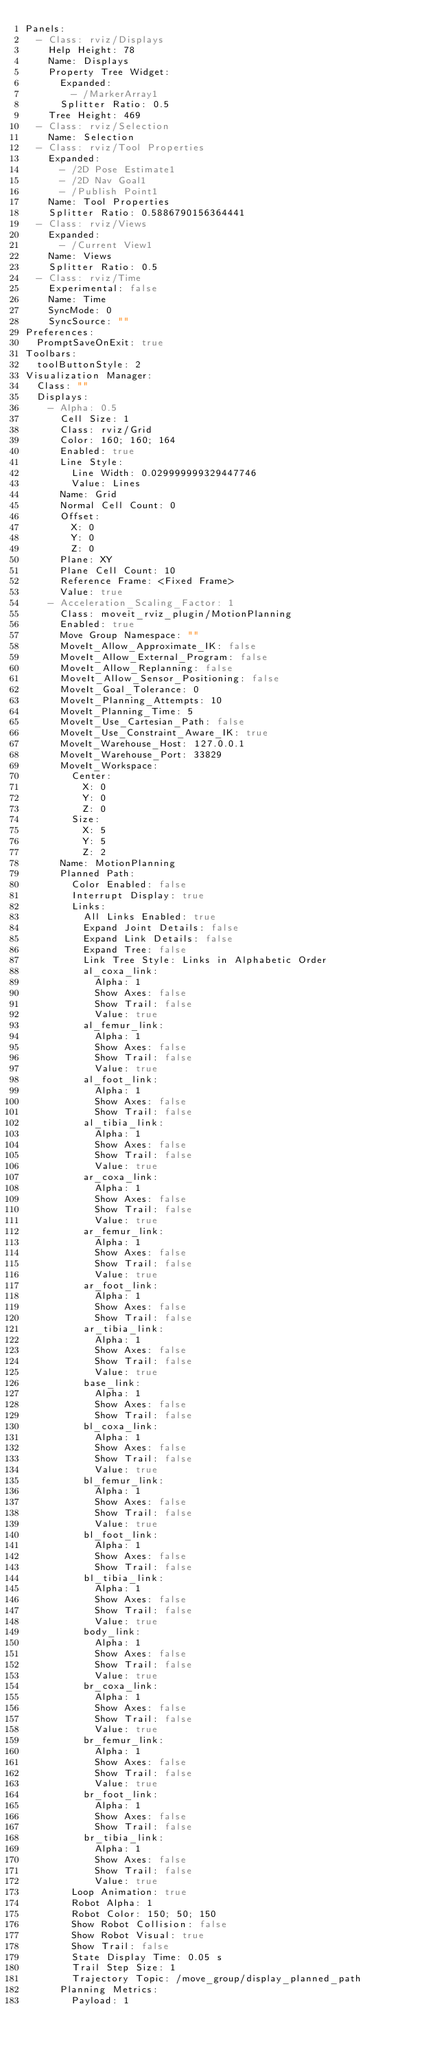<code> <loc_0><loc_0><loc_500><loc_500><_YAML_>Panels:
  - Class: rviz/Displays
    Help Height: 78
    Name: Displays
    Property Tree Widget:
      Expanded:
        - /MarkerArray1
      Splitter Ratio: 0.5
    Tree Height: 469
  - Class: rviz/Selection
    Name: Selection
  - Class: rviz/Tool Properties
    Expanded:
      - /2D Pose Estimate1
      - /2D Nav Goal1
      - /Publish Point1
    Name: Tool Properties
    Splitter Ratio: 0.5886790156364441
  - Class: rviz/Views
    Expanded:
      - /Current View1
    Name: Views
    Splitter Ratio: 0.5
  - Class: rviz/Time
    Experimental: false
    Name: Time
    SyncMode: 0
    SyncSource: ""
Preferences:
  PromptSaveOnExit: true
Toolbars:
  toolButtonStyle: 2
Visualization Manager:
  Class: ""
  Displays:
    - Alpha: 0.5
      Cell Size: 1
      Class: rviz/Grid
      Color: 160; 160; 164
      Enabled: true
      Line Style:
        Line Width: 0.029999999329447746
        Value: Lines
      Name: Grid
      Normal Cell Count: 0
      Offset:
        X: 0
        Y: 0
        Z: 0
      Plane: XY
      Plane Cell Count: 10
      Reference Frame: <Fixed Frame>
      Value: true
    - Acceleration_Scaling_Factor: 1
      Class: moveit_rviz_plugin/MotionPlanning
      Enabled: true
      Move Group Namespace: ""
      MoveIt_Allow_Approximate_IK: false
      MoveIt_Allow_External_Program: false
      MoveIt_Allow_Replanning: false
      MoveIt_Allow_Sensor_Positioning: false
      MoveIt_Goal_Tolerance: 0
      MoveIt_Planning_Attempts: 10
      MoveIt_Planning_Time: 5
      MoveIt_Use_Cartesian_Path: false
      MoveIt_Use_Constraint_Aware_IK: true
      MoveIt_Warehouse_Host: 127.0.0.1
      MoveIt_Warehouse_Port: 33829
      MoveIt_Workspace:
        Center:
          X: 0
          Y: 0
          Z: 0
        Size:
          X: 5
          Y: 5
          Z: 2
      Name: MotionPlanning
      Planned Path:
        Color Enabled: false
        Interrupt Display: true
        Links:
          All Links Enabled: true
          Expand Joint Details: false
          Expand Link Details: false
          Expand Tree: false
          Link Tree Style: Links in Alphabetic Order
          al_coxa_link:
            Alpha: 1
            Show Axes: false
            Show Trail: false
            Value: true
          al_femur_link:
            Alpha: 1
            Show Axes: false
            Show Trail: false
            Value: true
          al_foot_link:
            Alpha: 1
            Show Axes: false
            Show Trail: false
          al_tibia_link:
            Alpha: 1
            Show Axes: false
            Show Trail: false
            Value: true
          ar_coxa_link:
            Alpha: 1
            Show Axes: false
            Show Trail: false
            Value: true
          ar_femur_link:
            Alpha: 1
            Show Axes: false
            Show Trail: false
            Value: true
          ar_foot_link:
            Alpha: 1
            Show Axes: false
            Show Trail: false
          ar_tibia_link:
            Alpha: 1
            Show Axes: false
            Show Trail: false
            Value: true
          base_link:
            Alpha: 1
            Show Axes: false
            Show Trail: false
          bl_coxa_link:
            Alpha: 1
            Show Axes: false
            Show Trail: false
            Value: true
          bl_femur_link:
            Alpha: 1
            Show Axes: false
            Show Trail: false
            Value: true
          bl_foot_link:
            Alpha: 1
            Show Axes: false
            Show Trail: false
          bl_tibia_link:
            Alpha: 1
            Show Axes: false
            Show Trail: false
            Value: true
          body_link:
            Alpha: 1
            Show Axes: false
            Show Trail: false
            Value: true
          br_coxa_link:
            Alpha: 1
            Show Axes: false
            Show Trail: false
            Value: true
          br_femur_link:
            Alpha: 1
            Show Axes: false
            Show Trail: false
            Value: true
          br_foot_link:
            Alpha: 1
            Show Axes: false
            Show Trail: false
          br_tibia_link:
            Alpha: 1
            Show Axes: false
            Show Trail: false
            Value: true
        Loop Animation: true
        Robot Alpha: 1
        Robot Color: 150; 50; 150
        Show Robot Collision: false
        Show Robot Visual: true
        Show Trail: false
        State Display Time: 0.05 s
        Trail Step Size: 1
        Trajectory Topic: /move_group/display_planned_path
      Planning Metrics:
        Payload: 1</code> 